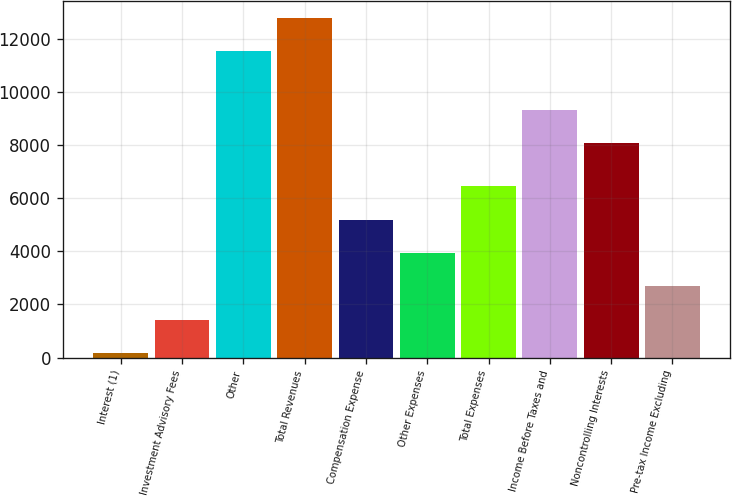Convert chart. <chart><loc_0><loc_0><loc_500><loc_500><bar_chart><fcel>Interest (1)<fcel>Investment Advisory Fees<fcel>Other<fcel>Total Revenues<fcel>Compensation Expense<fcel>Other Expenses<fcel>Total Expenses<fcel>Income Before Taxes and<fcel>Noncontrolling Interests<fcel>Pre-tax Income Excluding<nl><fcel>173<fcel>1429.9<fcel>11556<fcel>12812.9<fcel>5200.6<fcel>3943.7<fcel>6457.5<fcel>9323.9<fcel>8067<fcel>2686.8<nl></chart> 